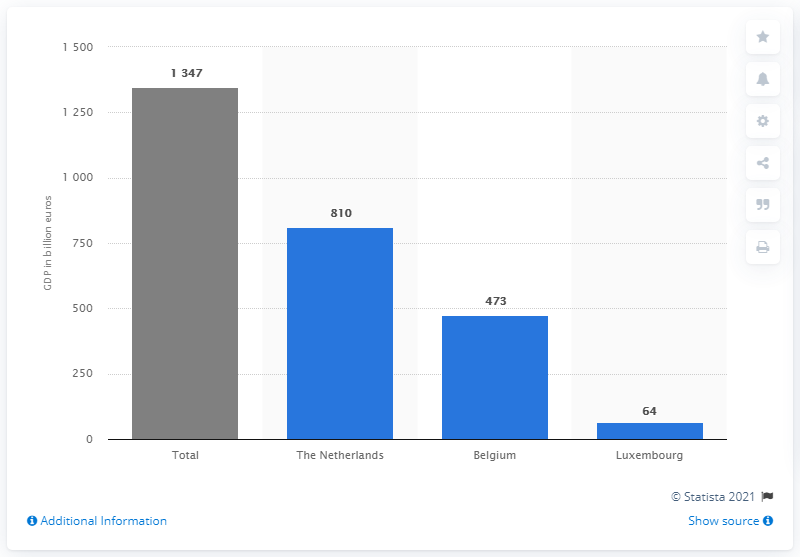Mention a couple of crucial points in this snapshot. In 2019, Belgium's Gross Domestic Product (GDP) was 473. In 2019, the Gross Domestic Product (GDP) of the Netherlands was 810 billion U.S. dollars. 